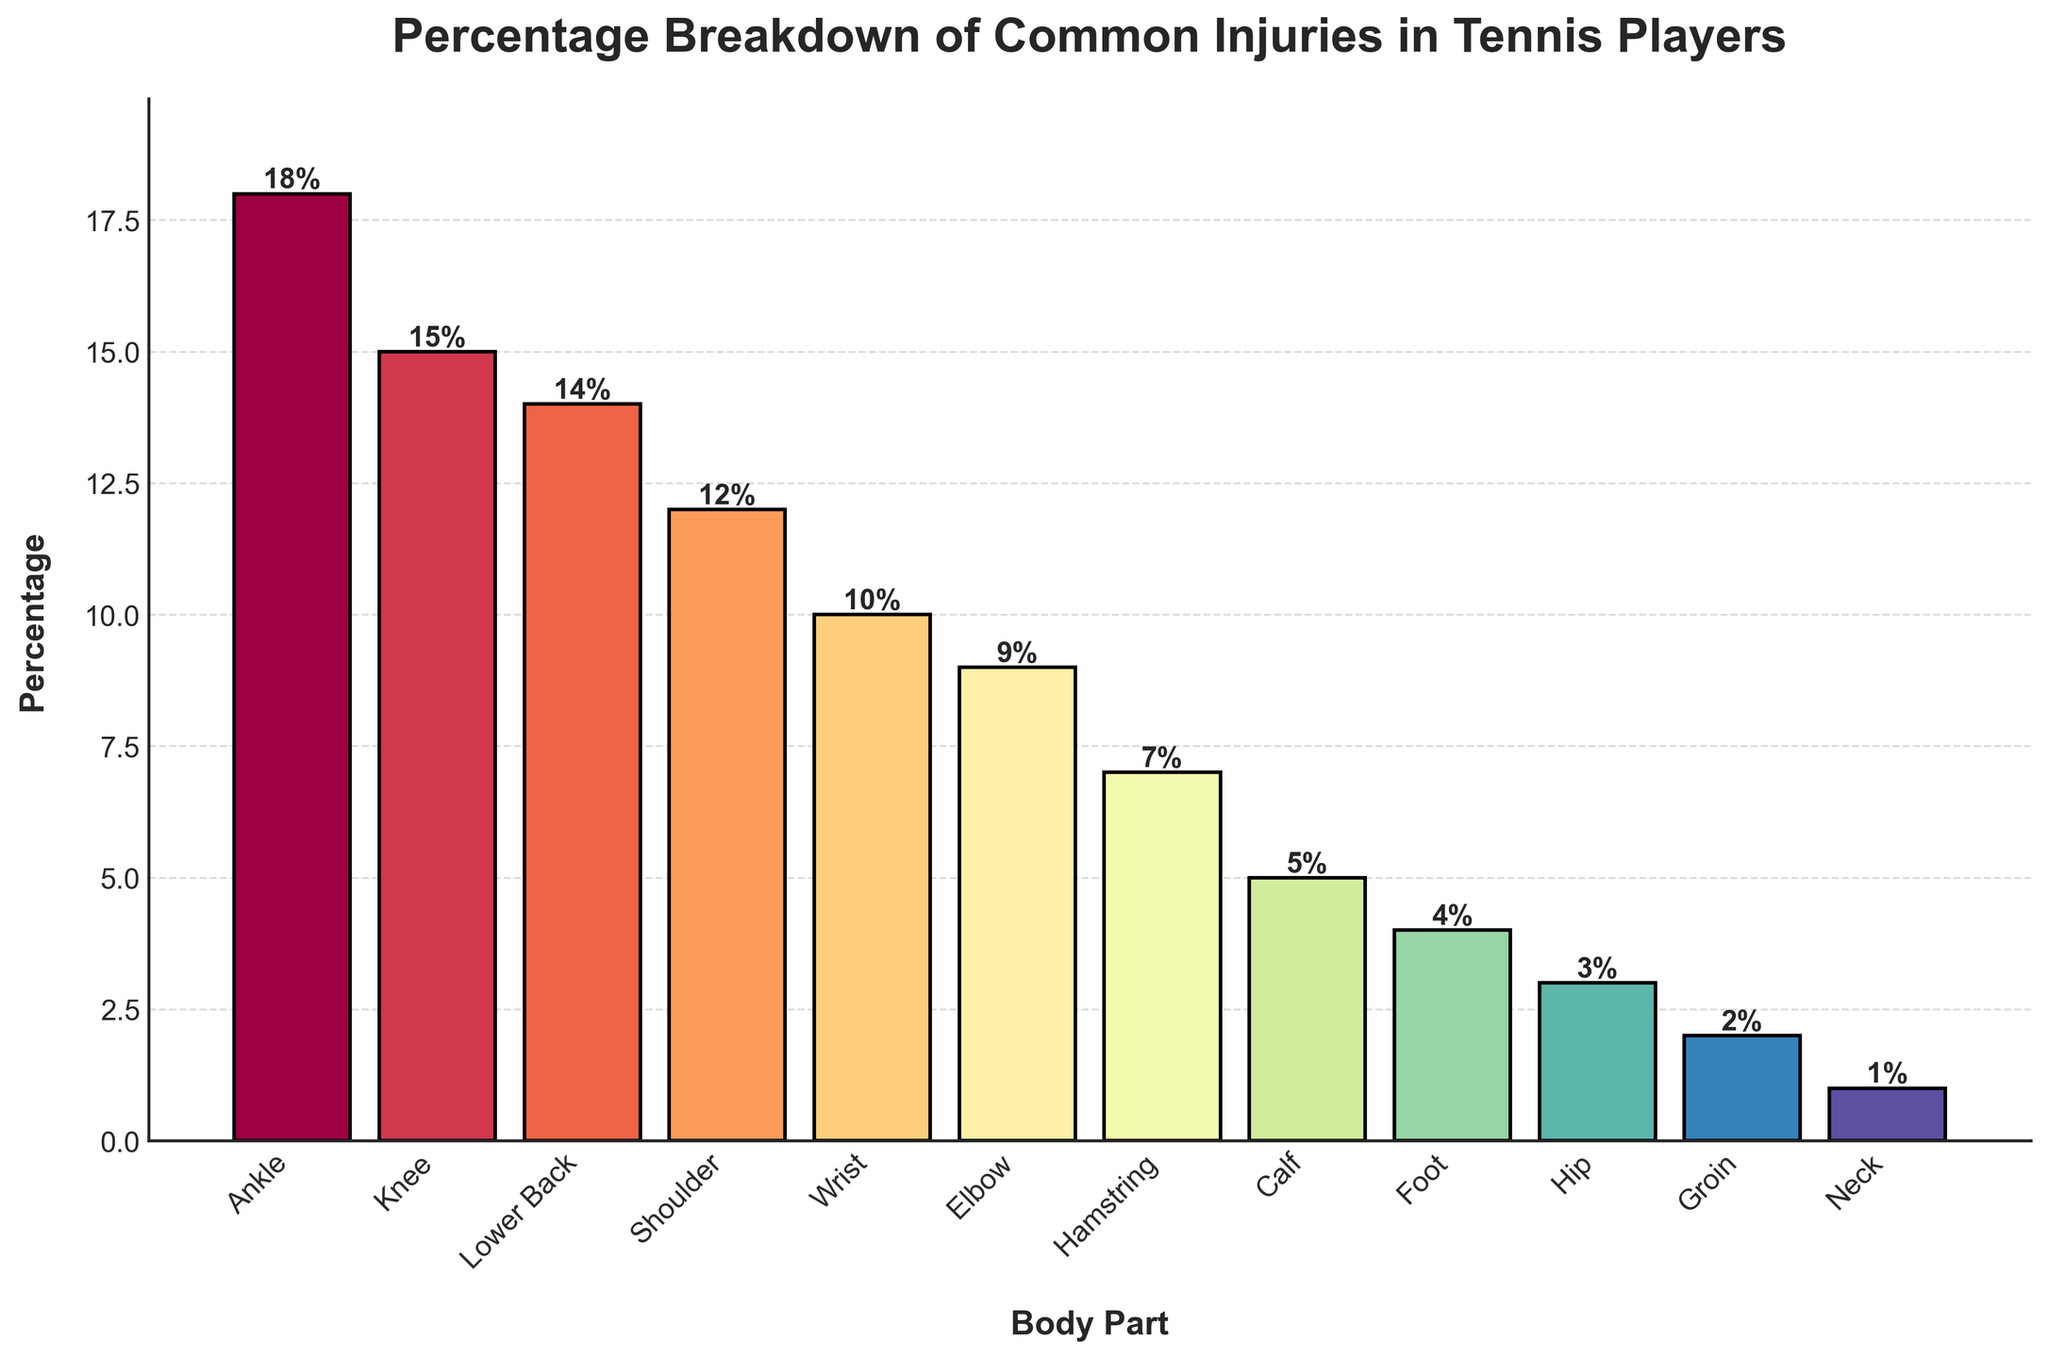What is the most common injury body part according to the chart? The tallest bar represents the body part with the highest percentage of injuries. The tallest bar is labeled "Ankle" with a value of 18%.
Answer: Ankle What is the least common injury body part according to the chart? The shortest bar represents the body part with the lowest percentage of injuries. The shortest bar is labeled "Neck" with a value of 1%.
Answer: Neck How much higher is the percentage of Ankle injuries compared to Knee injuries? The percentage of Ankle injuries is 18%, and the percentage of Knee injuries is 15%. Subtracting the two percentages gives 18% - 15% = 3%.
Answer: 3% Which two body parts have the same percentage of injuries? Reviewing the heights of the bars in the chart, no two bars have the same exact height percentage. All percentages are unique.
Answer: None What is the total percentage of injuries for the top three most injured body parts? The top three body parts by injury percentage are Ankle (18%), Knee (15%), and Lower Back (14%). Summing these values gives 18% + 15% + 14% = 47%.
Answer: 47% How many body parts have an injury percentage of 10% or more? Reviewing the bars, the body parts with a percentage of 10% or more are Ankle (18%), Knee (15%), Lower Back (14%), Shoulder (12%), and Wrist (10%). That's a total of 5 body parts.
Answer: 5 Arrange the body parts in descending order of injury percentage. Review the bars from tallest to shortest and list them accordingly: Ankle (18%), Knee (15%), Lower Back (14%), Shoulder (12%), Wrist (10%), Elbow (9%), Hamstring (7%), Calf (5%), Foot (4%), Hip (3%), Groin (2%), Neck (1%).
Answer: Ankle, Knee, Lower Back, Shoulder, Wrist, Elbow, Hamstring, Calf, Foot, Hip, Groin, Neck What is the combined percentage of injuries for Hip, Groin, and Neck? The percentages for Hip, Groin, and Neck are 3%, 2%, and 1%, respectively. Summing these values gives 3% + 2% + 1% = 6%.
Answer: 6% Which body part has a slightly higher percentage of injuries, Hamstring or Elbow? Reviewing the chart, the Hamstring has an injury percentage of 7%, whereas the Elbow has a percentage of 9%. Comparing these, Elbow has a slightly higher percentage of injuries than Hamstring.
Answer: Elbow Which body part contributes to the overall injury percentage just below Knee injuries according to the data? The percentage of Knee injuries is 15%, and the body part just below it in percentage terms is Lower Back with 14%.
Answer: Lower Back 